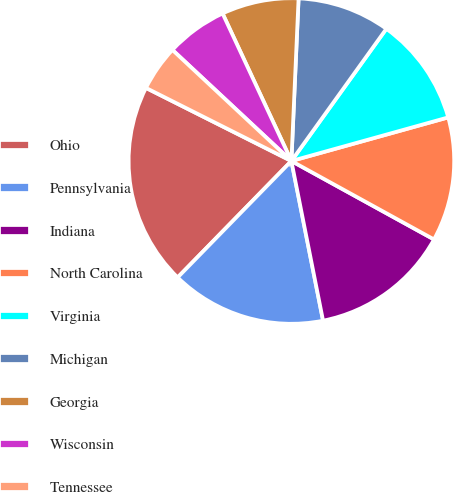Convert chart. <chart><loc_0><loc_0><loc_500><loc_500><pie_chart><fcel>Ohio<fcel>Pennsylvania<fcel>Indiana<fcel>North Carolina<fcel>Virginia<fcel>Michigan<fcel>Georgia<fcel>Wisconsin<fcel>Tennessee<nl><fcel>20.1%<fcel>15.43%<fcel>13.88%<fcel>12.32%<fcel>10.77%<fcel>9.21%<fcel>7.65%<fcel>6.1%<fcel>4.54%<nl></chart> 